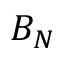<formula> <loc_0><loc_0><loc_500><loc_500>B _ { N }</formula> 